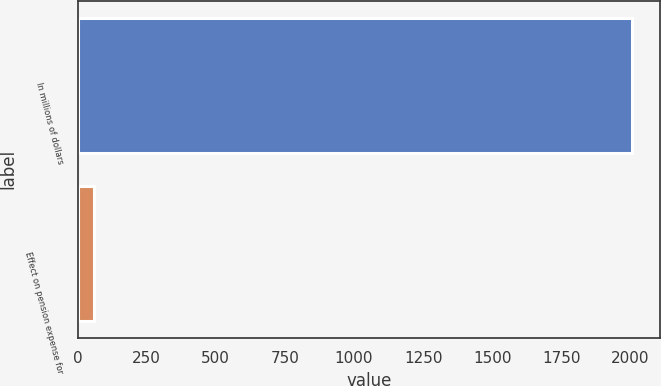Convert chart to OTSL. <chart><loc_0><loc_0><loc_500><loc_500><bar_chart><fcel>In millions of dollars<fcel>Effect on pension expense for<nl><fcel>2006<fcel>61<nl></chart> 